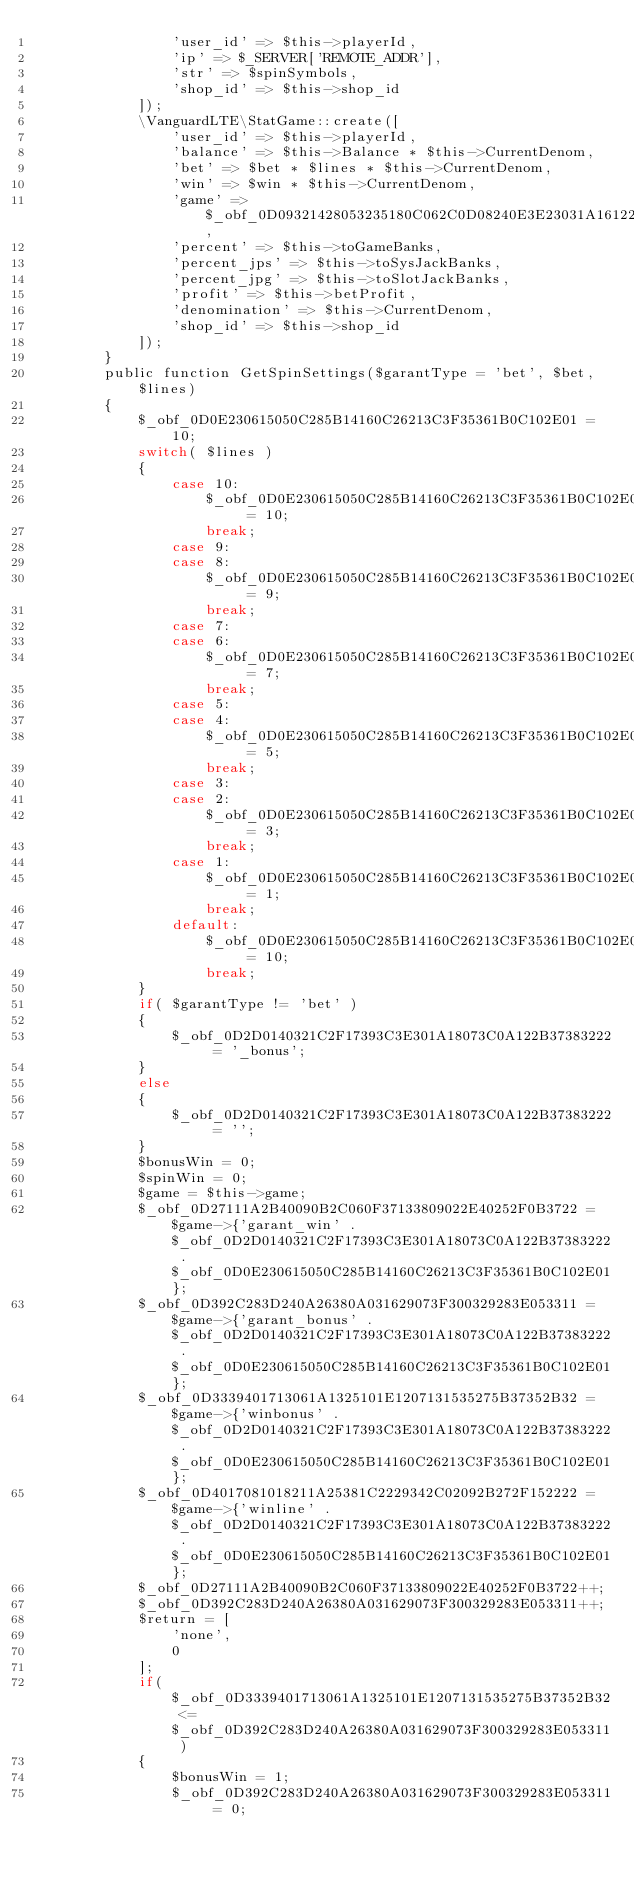Convert code to text. <code><loc_0><loc_0><loc_500><loc_500><_PHP_>                'user_id' => $this->playerId, 
                'ip' => $_SERVER['REMOTE_ADDR'], 
                'str' => $spinSymbols, 
                'shop_id' => $this->shop_id
            ]);
            \VanguardLTE\StatGame::create([
                'user_id' => $this->playerId, 
                'balance' => $this->Balance * $this->CurrentDenom, 
                'bet' => $bet * $lines * $this->CurrentDenom, 
                'win' => $win * $this->CurrentDenom, 
                'game' => $_obf_0D09321428053235180C062C0D08240E3E23031A161222, 
                'percent' => $this->toGameBanks, 
                'percent_jps' => $this->toSysJackBanks, 
                'percent_jpg' => $this->toSlotJackBanks, 
                'profit' => $this->betProfit, 
                'denomination' => $this->CurrentDenom, 
                'shop_id' => $this->shop_id
            ]);
        }
        public function GetSpinSettings($garantType = 'bet', $bet, $lines)
        {
            $_obf_0D0E230615050C285B14160C26213C3F35361B0C102E01 = 10;
            switch( $lines ) 
            {
                case 10:
                    $_obf_0D0E230615050C285B14160C26213C3F35361B0C102E01 = 10;
                    break;
                case 9:
                case 8:
                    $_obf_0D0E230615050C285B14160C26213C3F35361B0C102E01 = 9;
                    break;
                case 7:
                case 6:
                    $_obf_0D0E230615050C285B14160C26213C3F35361B0C102E01 = 7;
                    break;
                case 5:
                case 4:
                    $_obf_0D0E230615050C285B14160C26213C3F35361B0C102E01 = 5;
                    break;
                case 3:
                case 2:
                    $_obf_0D0E230615050C285B14160C26213C3F35361B0C102E01 = 3;
                    break;
                case 1:
                    $_obf_0D0E230615050C285B14160C26213C3F35361B0C102E01 = 1;
                    break;
                default:
                    $_obf_0D0E230615050C285B14160C26213C3F35361B0C102E01 = 10;
                    break;
            }
            if( $garantType != 'bet' ) 
            {
                $_obf_0D2D0140321C2F17393C3E301A18073C0A122B37383222 = '_bonus';
            }
            else
            {
                $_obf_0D2D0140321C2F17393C3E301A18073C0A122B37383222 = '';
            }
            $bonusWin = 0;
            $spinWin = 0;
            $game = $this->game;
            $_obf_0D27111A2B40090B2C060F37133809022E40252F0B3722 = $game->{'garant_win' . $_obf_0D2D0140321C2F17393C3E301A18073C0A122B37383222 . $_obf_0D0E230615050C285B14160C26213C3F35361B0C102E01};
            $_obf_0D392C283D240A26380A031629073F300329283E053311 = $game->{'garant_bonus' . $_obf_0D2D0140321C2F17393C3E301A18073C0A122B37383222 . $_obf_0D0E230615050C285B14160C26213C3F35361B0C102E01};
            $_obf_0D3339401713061A1325101E1207131535275B37352B32 = $game->{'winbonus' . $_obf_0D2D0140321C2F17393C3E301A18073C0A122B37383222 . $_obf_0D0E230615050C285B14160C26213C3F35361B0C102E01};
            $_obf_0D4017081018211A25381C2229342C02092B272F152222 = $game->{'winline' . $_obf_0D2D0140321C2F17393C3E301A18073C0A122B37383222 . $_obf_0D0E230615050C285B14160C26213C3F35361B0C102E01};
            $_obf_0D27111A2B40090B2C060F37133809022E40252F0B3722++;
            $_obf_0D392C283D240A26380A031629073F300329283E053311++;
            $return = [
                'none', 
                0
            ];
            if( $_obf_0D3339401713061A1325101E1207131535275B37352B32 <= $_obf_0D392C283D240A26380A031629073F300329283E053311 ) 
            {
                $bonusWin = 1;
                $_obf_0D392C283D240A26380A031629073F300329283E053311 = 0;</code> 